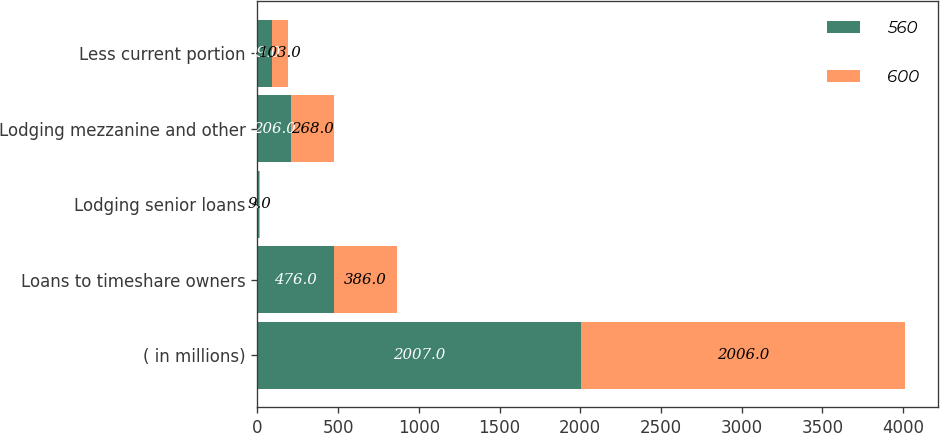Convert chart to OTSL. <chart><loc_0><loc_0><loc_500><loc_500><stacked_bar_chart><ecel><fcel>( in millions)<fcel>Loans to timeshare owners<fcel>Lodging senior loans<fcel>Lodging mezzanine and other<fcel>Less current portion<nl><fcel>560<fcel>2007<fcel>476<fcel>7<fcel>206<fcel>89<nl><fcel>600<fcel>2006<fcel>386<fcel>9<fcel>268<fcel>103<nl></chart> 